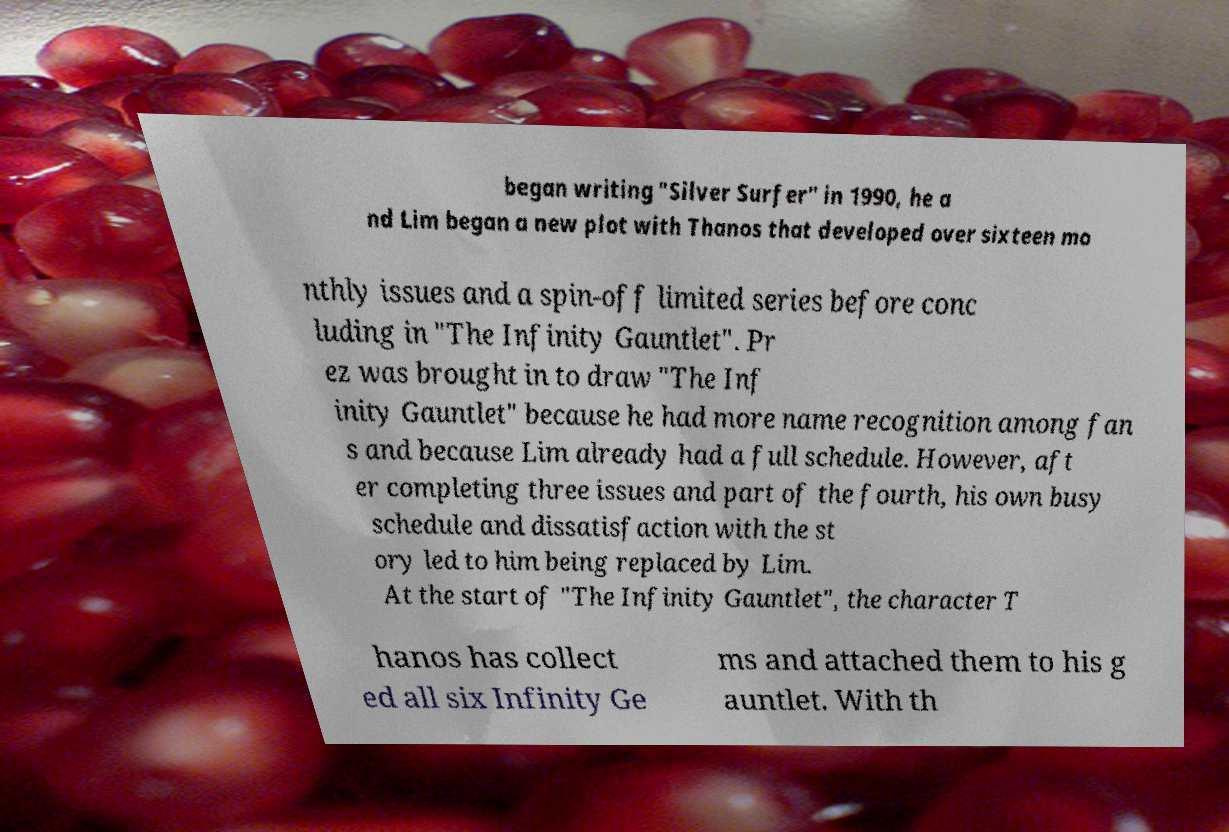Please identify and transcribe the text found in this image. began writing "Silver Surfer" in 1990, he a nd Lim began a new plot with Thanos that developed over sixteen mo nthly issues and a spin-off limited series before conc luding in "The Infinity Gauntlet". Pr ez was brought in to draw "The Inf inity Gauntlet" because he had more name recognition among fan s and because Lim already had a full schedule. However, aft er completing three issues and part of the fourth, his own busy schedule and dissatisfaction with the st ory led to him being replaced by Lim. At the start of "The Infinity Gauntlet", the character T hanos has collect ed all six Infinity Ge ms and attached them to his g auntlet. With th 